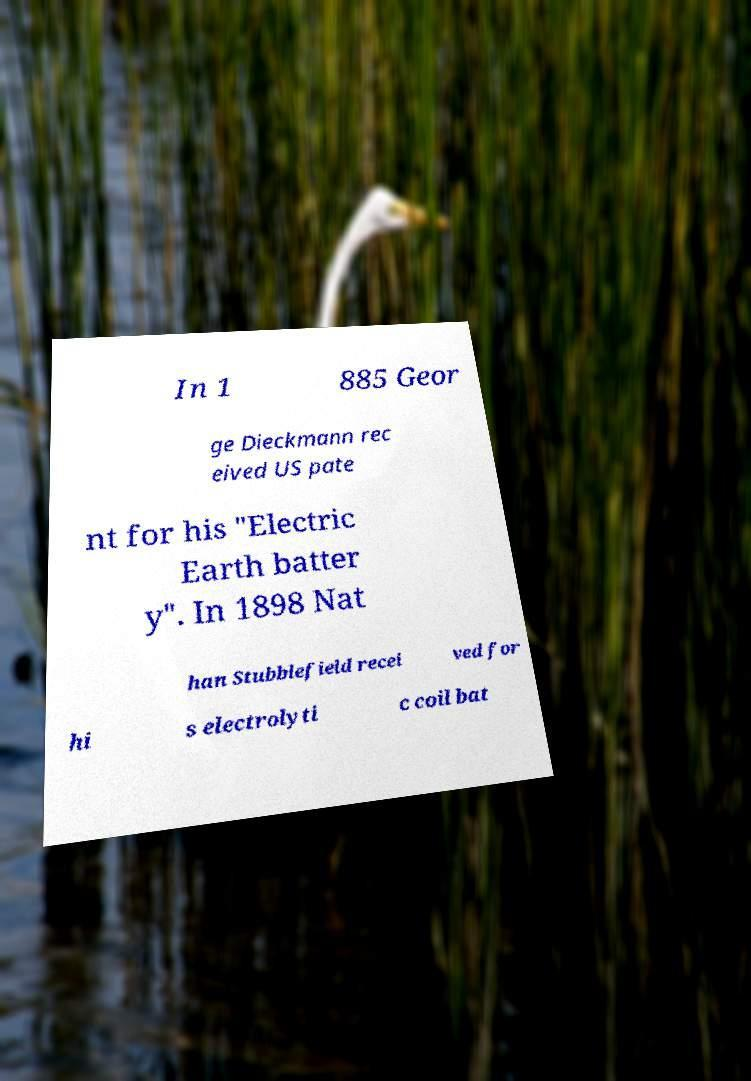There's text embedded in this image that I need extracted. Can you transcribe it verbatim? In 1 885 Geor ge Dieckmann rec eived US pate nt for his "Electric Earth batter y". In 1898 Nat han Stubblefield recei ved for hi s electrolyti c coil bat 